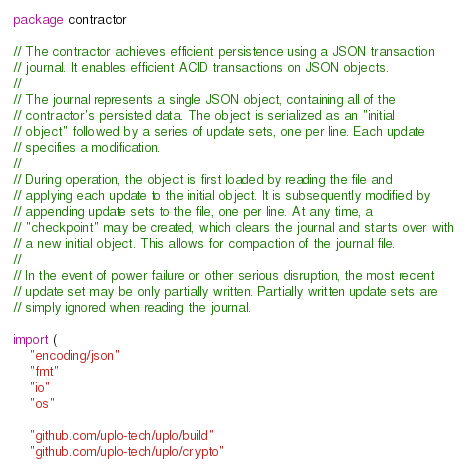<code> <loc_0><loc_0><loc_500><loc_500><_Go_>package contractor

// The contractor achieves efficient persistence using a JSON transaction
// journal. It enables efficient ACID transactions on JSON objects.
//
// The journal represents a single JSON object, containing all of the
// contractor's persisted data. The object is serialized as an "initial
// object" followed by a series of update sets, one per line. Each update
// specifies a modification.
//
// During operation, the object is first loaded by reading the file and
// applying each update to the initial object. It is subsequently modified by
// appending update sets to the file, one per line. At any time, a
// "checkpoint" may be created, which clears the journal and starts over with
// a new initial object. This allows for compaction of the journal file.
//
// In the event of power failure or other serious disruption, the most recent
// update set may be only partially written. Partially written update sets are
// simply ignored when reading the journal.

import (
	"encoding/json"
	"fmt"
	"io"
	"os"

	"github.com/uplo-tech/uplo/build"
	"github.com/uplo-tech/uplo/crypto"</code> 